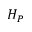Convert formula to latex. <formula><loc_0><loc_0><loc_500><loc_500>H _ { P }</formula> 